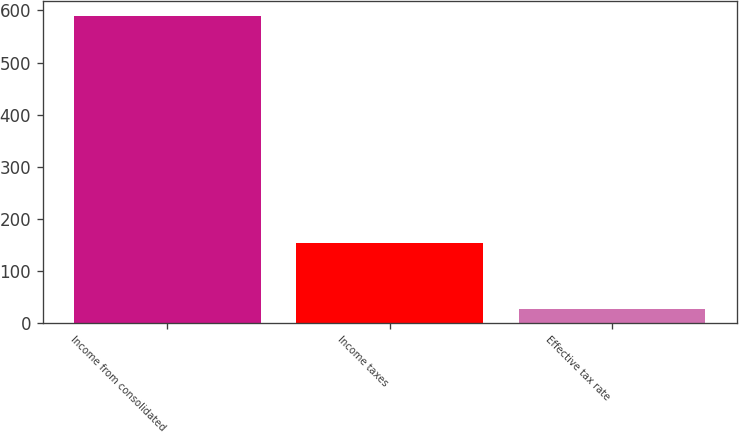Convert chart. <chart><loc_0><loc_0><loc_500><loc_500><bar_chart><fcel>Income from consolidated<fcel>Income taxes<fcel>Effective tax rate<nl><fcel>589.2<fcel>153<fcel>26<nl></chart> 